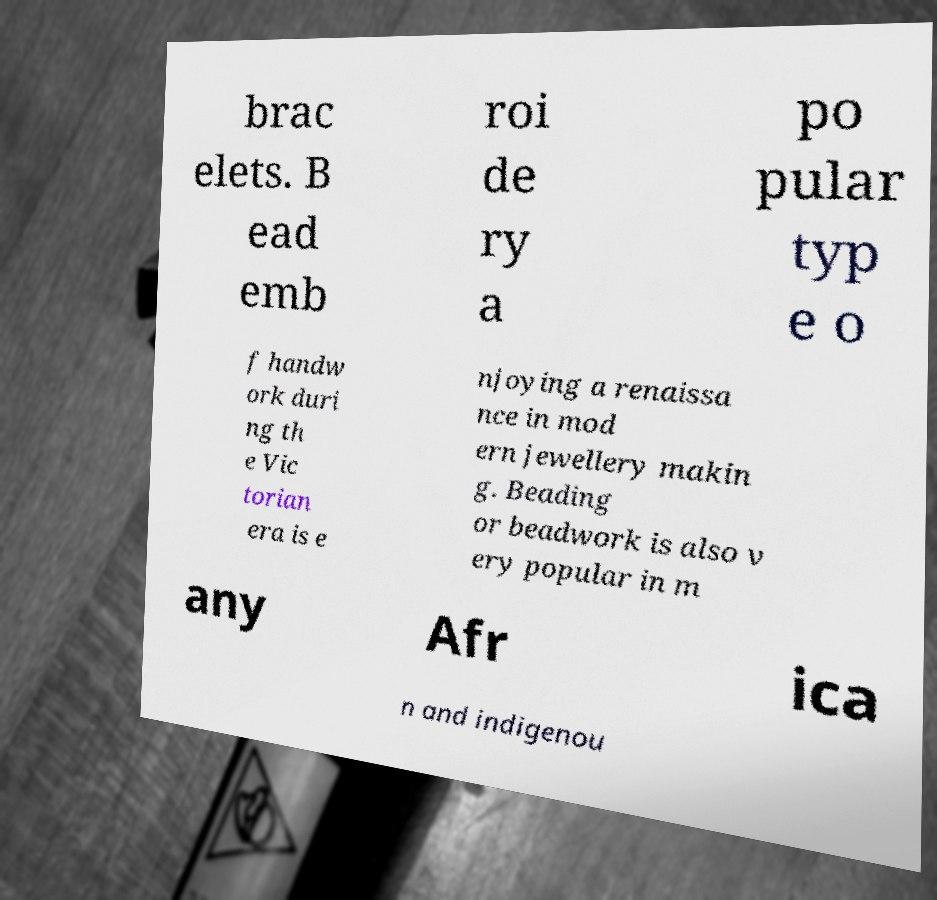For documentation purposes, I need the text within this image transcribed. Could you provide that? brac elets. B ead emb roi de ry a po pular typ e o f handw ork duri ng th e Vic torian era is e njoying a renaissa nce in mod ern jewellery makin g. Beading or beadwork is also v ery popular in m any Afr ica n and indigenou 